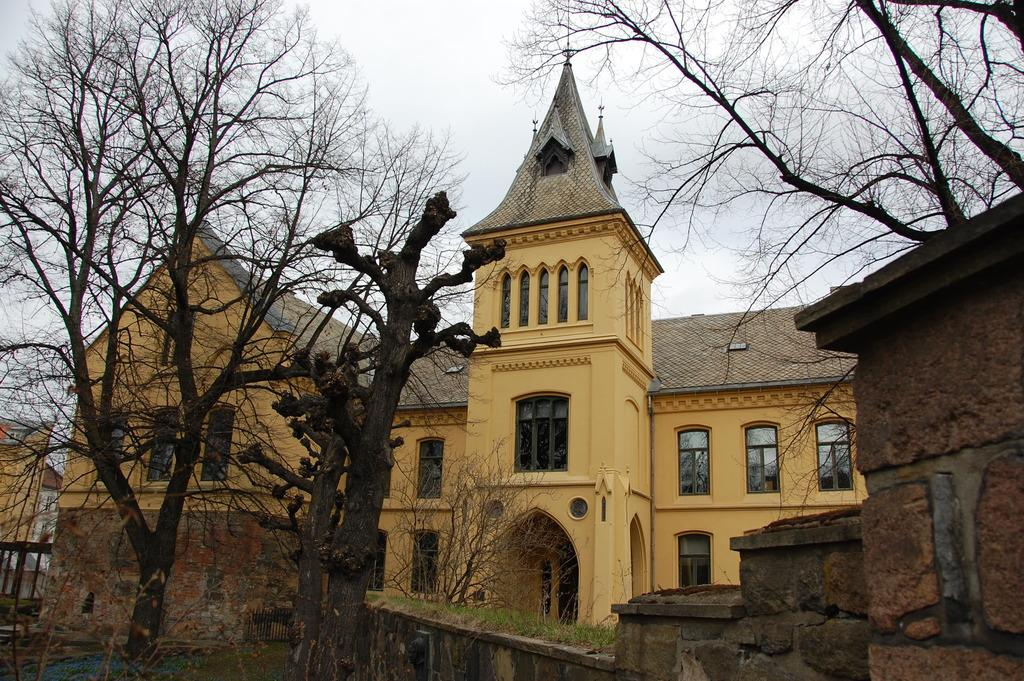Where was the picture taken? The picture was clicked outside. What can be seen in the foreground of the image? There is a small portion of grass and trees in the foreground. What type of structures can be seen in the image? There are buildings visible in the image. What part of the natural environment is visible in the image? The sky is visible in the image. What architectural feature can be seen on the buildings? There are windows present in the image. How many tests are being conducted on the grass in the image? There is no indication of any tests being conducted on the grass in the image. What type of lock can be seen securing the windows in the image? There is no lock visible on the windows in the image. 